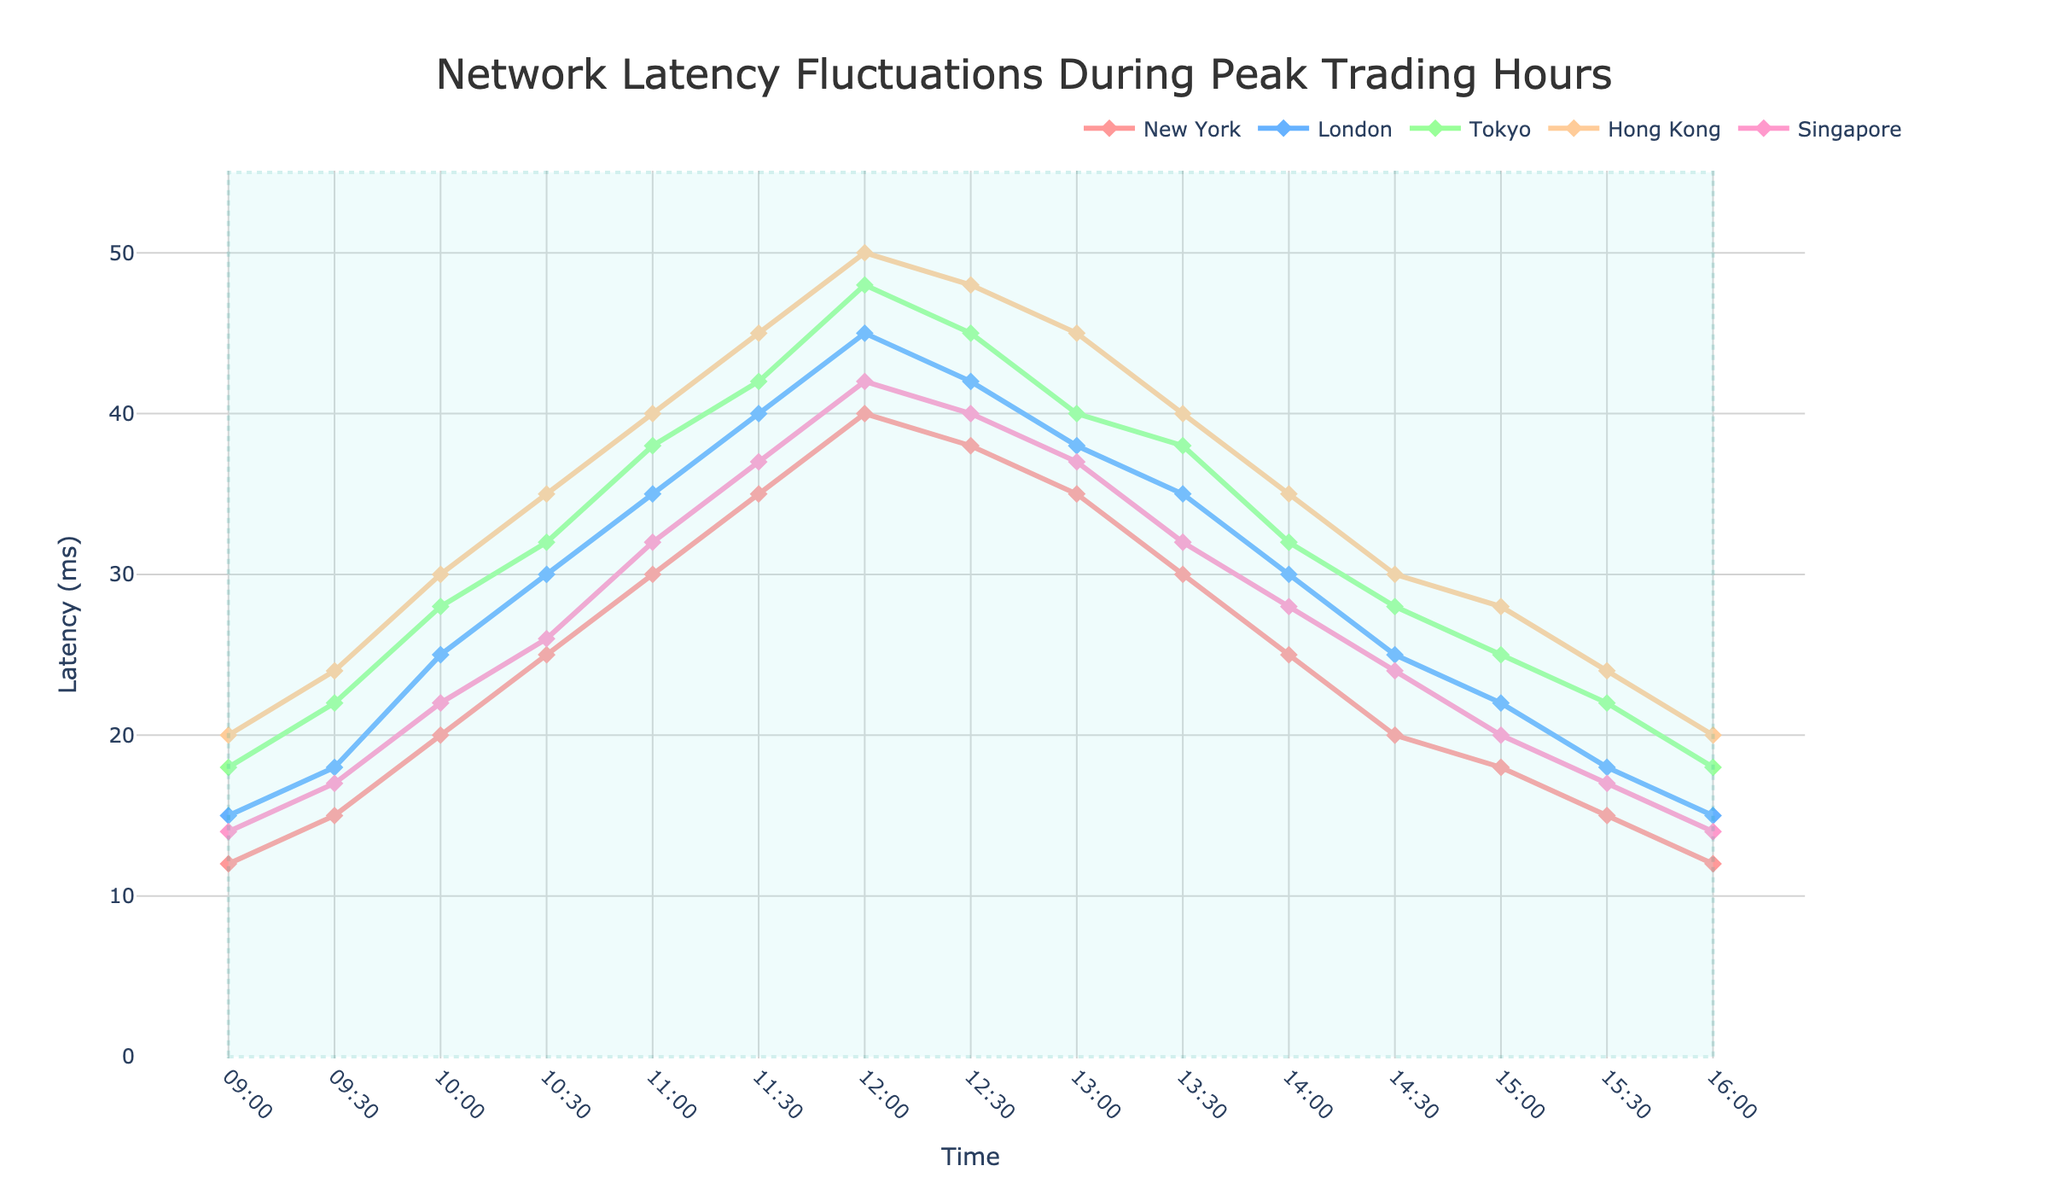What is the latency in New York at 10:00? By looking at the figure, find the data point corresponding to "New York" at 10:00.
Answer: 20 ms Which location has the highest latency at 12:00? Identify the highest point among all locations at 12:00 by comparing the data points visually on the figure.
Answer: Hong Kong Compare the latency levels between London and Tokyo at 11:30. Which location has higher latency? Find the data points for London and Tokyo at 11:30 in the figure and compare them.
Answer: Tokyo What is the difference in latency between Singapore and New York at their respective highest points? Identify the peak latency for both Singapore and New York in the figure, then subtract the New York peak from the Singapore peak.
Answer: 10 ms (Hong Kong has 50 ms and New York has 40 ms at their peaks) During which time block does Singapore have the lowest latency, and what is it? Visually scan the Singapore latency line in the figure to identify the lowest point and its corresponding time block.
Answer: 09:00 and 16:00, 14 ms What is the average latency for Tokyo between 09:00 and 12:00? Sum the latencies for Tokyo at 09:00 (18), 09:30 (22), 10:00 (28), 10:30 (32), 11:00 (38), and 11:30 (42), and divide by the number of points (6).
Answer: 30 ms What is the trend of Hong Kong's latency from 09:00 to 12:30? Analyze the Hong Kong latency line from 09:00 to 12:30, identify if it is generally increasing, decreasing, or fluctuating.
Answer: Increasing Compare the latencies at 14:00 for New York and Singapore, and determine the difference. Find the data points for New York and Singapore at 14:00 in the figure, then subtract them.
Answer: 5 ms (28-23) During which timeframe is the latency above 40 ms for London? Look at the line for London and identify the time blocks where the latency crosses above 40 ms.
Answer: 11:30 to 12:30 Visualize the shapes on the figure and explain their purpose. The shapes on the figure (such as the shaded area) are used to highlight the entire trading day from 09:00 to 16:00.
Answer: Highlight peak trading hours 